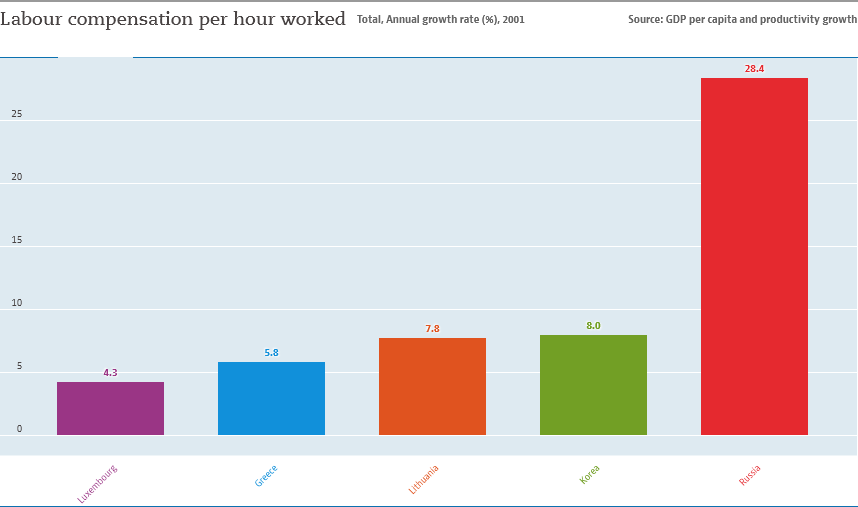Identify some key points in this picture. Russia is the country represented by the red bar. The average value of Korea, Greece, and Russia is 14.06. 